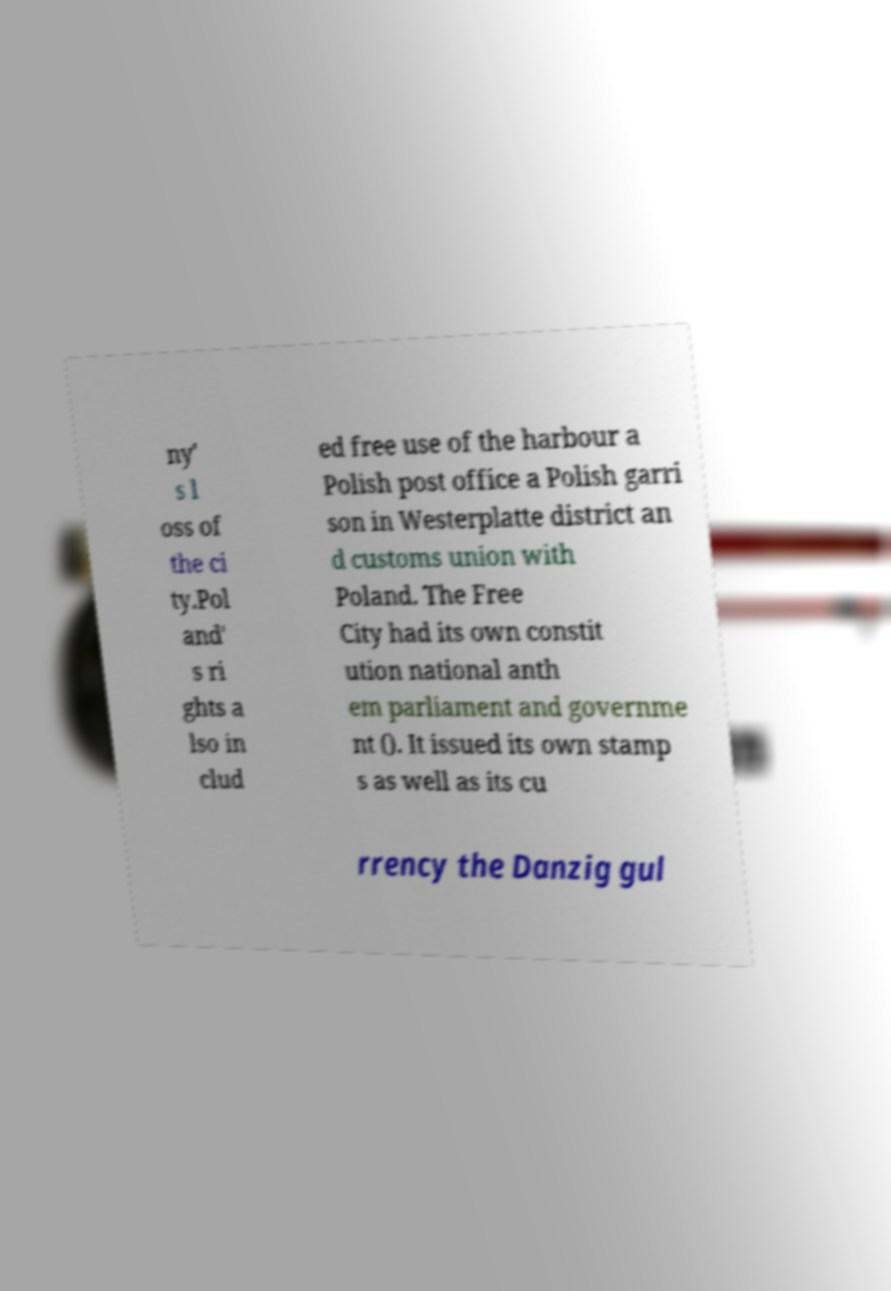Could you assist in decoding the text presented in this image and type it out clearly? ny' s l oss of the ci ty.Pol and' s ri ghts a lso in clud ed free use of the harbour a Polish post office a Polish garri son in Westerplatte district an d customs union with Poland. The Free City had its own constit ution national anth em parliament and governme nt (). It issued its own stamp s as well as its cu rrency the Danzig gul 